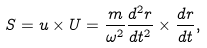<formula> <loc_0><loc_0><loc_500><loc_500>S = u \times U = \frac { m } { \omega ^ { 2 } } \frac { d ^ { 2 } r } { d t ^ { 2 } } \times \frac { d r } { d t } ,</formula> 